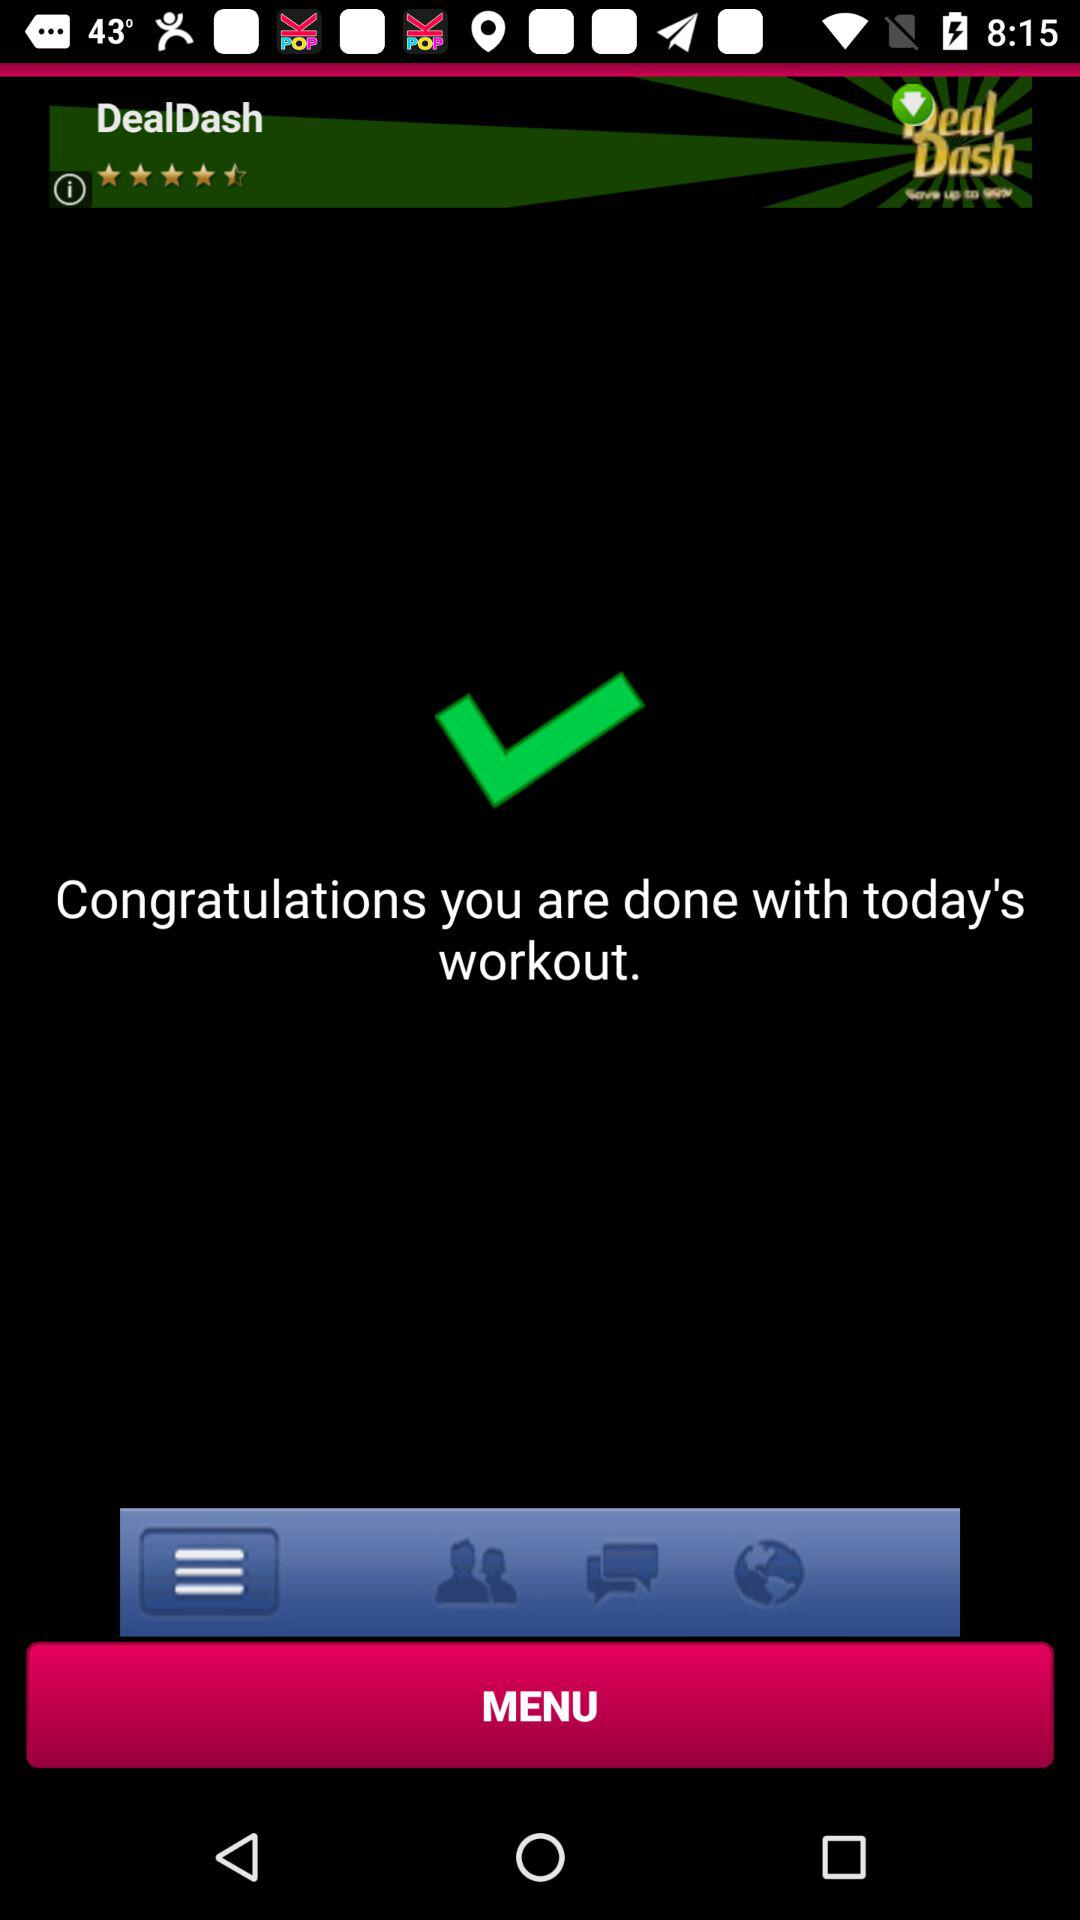What is the rating for "DealDash"? The rating is 4.5 stars. 